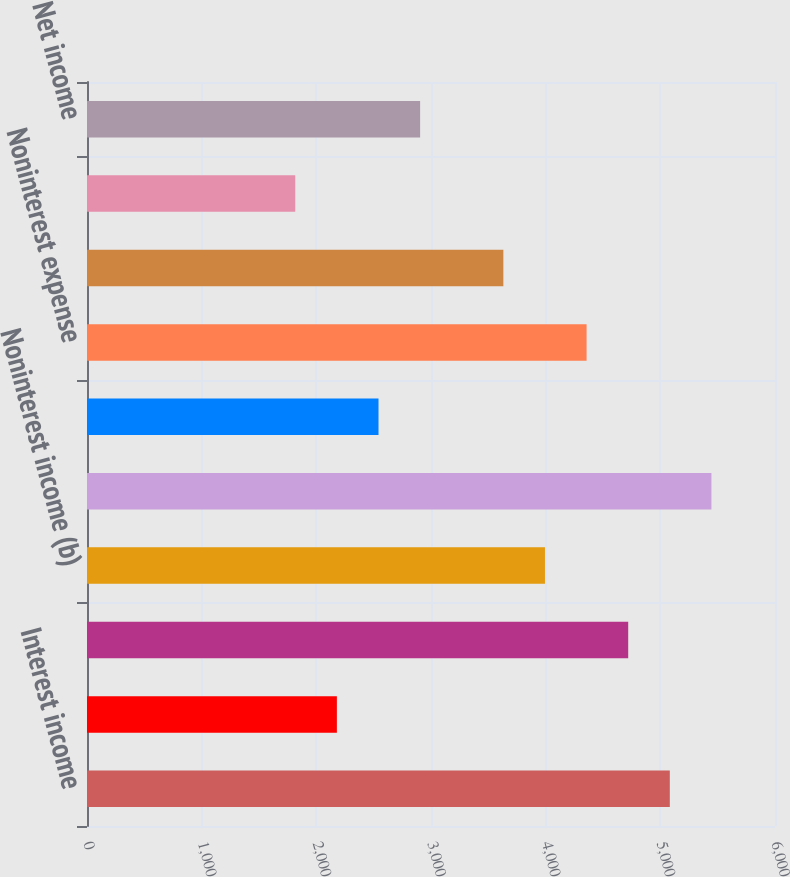<chart> <loc_0><loc_0><loc_500><loc_500><bar_chart><fcel>Interest income<fcel>Interest expense<fcel>Net interest income<fcel>Noninterest income (b)<fcel>Total revenue<fcel>Provision for credit losses<fcel>Noninterest expense<fcel>Income from continuing<fcel>Income taxes<fcel>Net income<nl><fcel>5082.73<fcel>2179.21<fcel>4719.79<fcel>3993.91<fcel>5445.67<fcel>2542.15<fcel>4356.85<fcel>3630.97<fcel>1816.27<fcel>2905.09<nl></chart> 